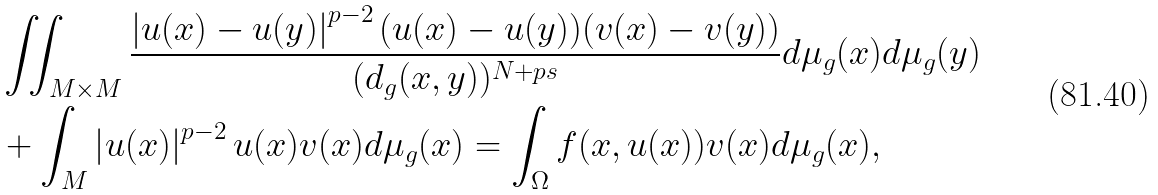<formula> <loc_0><loc_0><loc_500><loc_500>& \iint _ { M \times M } \frac { \left | u ( x ) - u ( y ) \right | ^ { p - 2 } ( u ( x ) - u ( y ) ) ( v ( x ) - v ( y ) ) } { ( d _ { g } ( x , y ) ) ^ { N + p s } } d \mu _ { g } ( x ) d \mu _ { g } ( y ) \\ & + \int _ { M } \left | u ( x ) \right | ^ { p - 2 } u ( x ) v ( x ) d \mu _ { g } ( x ) = \int _ { \Omega } f ( x , u ( x ) ) v ( x ) d \mu _ { g } ( x ) ,</formula> 